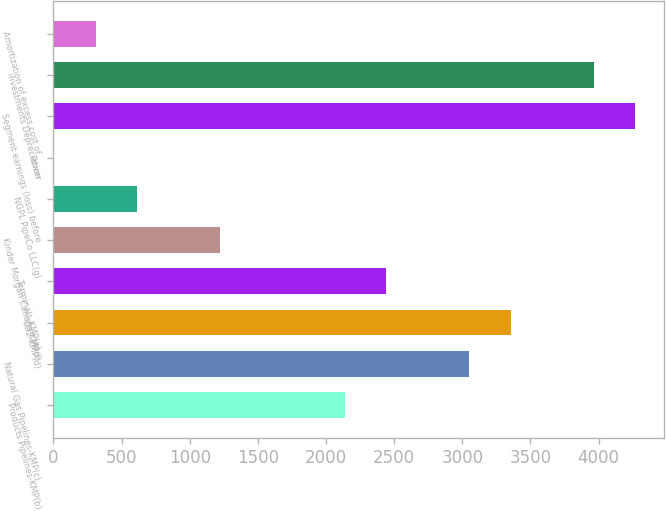Convert chart. <chart><loc_0><loc_0><loc_500><loc_500><bar_chart><fcel>Products Pipelines-KMP(b)<fcel>Natural Gas Pipelines-KMP(c)<fcel>CO2-KMP(d)<fcel>Terminals-KMP(e)<fcel>Kinder Morgan Canada-KMP(f)<fcel>NGPL PipeCo LLC(g)<fcel>Power<fcel>Segment earnings (loss) before<fcel>investments Depreciation<fcel>Amortization of excess cost of<nl><fcel>2136.02<fcel>3049.4<fcel>3353.86<fcel>2440.48<fcel>1222.64<fcel>613.72<fcel>4.8<fcel>4267.24<fcel>3962.78<fcel>309.26<nl></chart> 